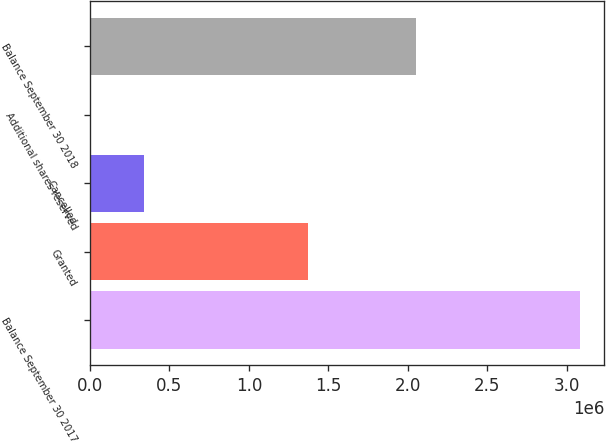Convert chart. <chart><loc_0><loc_0><loc_500><loc_500><bar_chart><fcel>Balance September 30 2017<fcel>Granted<fcel>Cancelled<fcel>Additional shares reserved<fcel>Balance September 30 2018<nl><fcel>3.08128e+06<fcel>1.36998e+06<fcel>341000<fcel>613<fcel>2.05169e+06<nl></chart> 